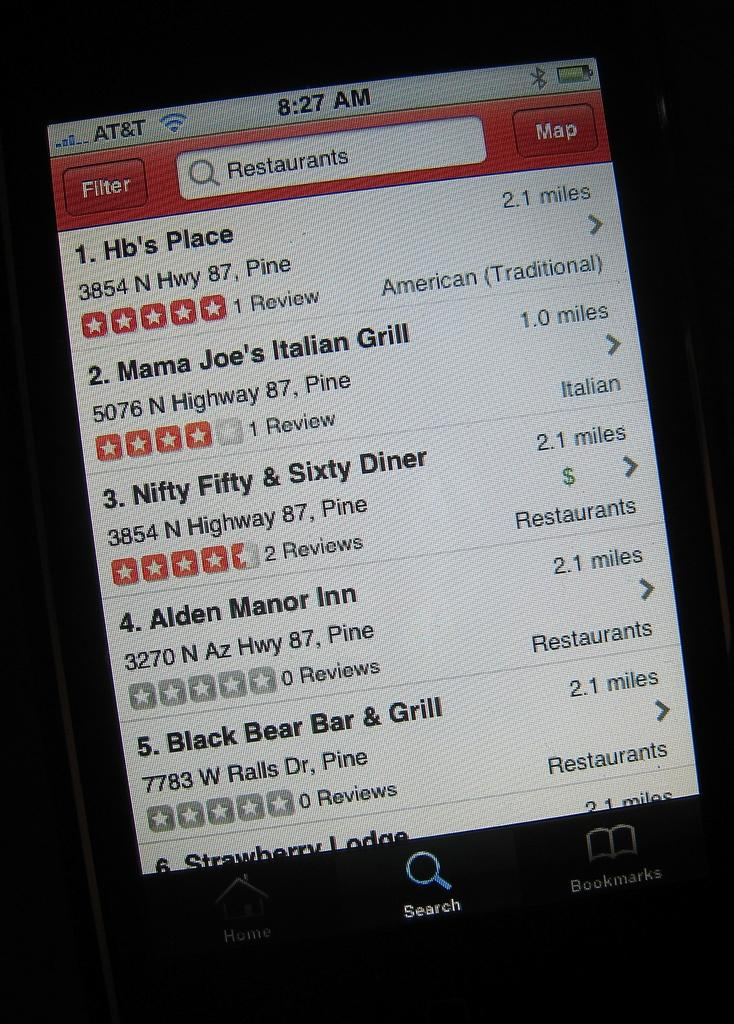<image>
Write a terse but informative summary of the picture. A smartphone screen showing Hb's Place in first place 